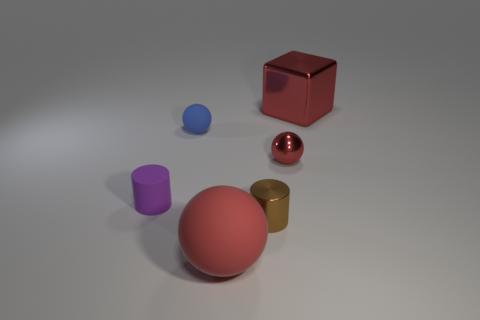The large rubber object that is the same color as the metallic ball is what shape?
Give a very brief answer. Sphere. The matte thing that is the same color as the small metallic sphere is what size?
Provide a succinct answer. Large. Is the size of the blue thing that is left of the red metal cube the same as the purple thing?
Keep it short and to the point. Yes. There is a large thing to the left of the shiny ball; what shape is it?
Your answer should be compact. Sphere. Is the number of rubber objects greater than the number of purple matte cylinders?
Your answer should be very brief. Yes. Is the color of the sphere right of the brown thing the same as the matte cylinder?
Your answer should be compact. No. How many objects are small matte things in front of the blue matte thing or rubber objects that are on the left side of the red matte sphere?
Give a very brief answer. 2. What number of rubber things are both in front of the small red sphere and to the right of the purple cylinder?
Your answer should be compact. 1. Does the tiny blue ball have the same material as the tiny red ball?
Your answer should be compact. No. What shape is the metal object that is on the right side of the tiny sphere that is to the right of the rubber thing that is in front of the tiny brown metallic object?
Your answer should be compact. Cube. 